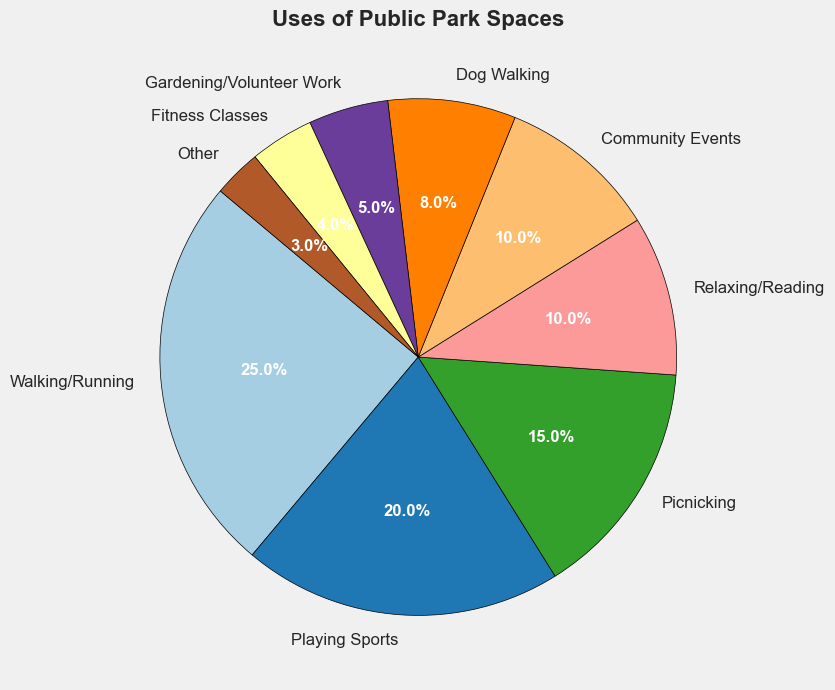What's the largest category of park usage? The figure shows the categories and their corresponding percentages. The largest wedge corresponds to Walking/Running, which takes up 25% of the pie chart.
Answer: Walking/Running Which category uses the least percentage of the park space? By looking at the smallest wedge, we can see that the category "Other" takes up the least percentage of the pie chart at 3%.
Answer: Other How much more percentage is spent on Playing Sports compared to Fitness Classes? Playing Sports accounts for 20% of the pie chart, while Fitness Classes account for 4%. Subtracting the percentage for Fitness Classes from the percentage for Playing Sports (20% - 4%), we get 16%.
Answer: 16% What is the combined percentage for community-oriented activities (Community Events and Gardening/Volunteer Work)? Community Events is 10% and Gardening/Volunteer Work is 5%. Adding these percentages together (10% + 5%), we get a combined percentage of 15%.
Answer: 15% Is the percentage of Dog Walking greater than that of Picnicking? The figure shows that Dog Walking is 8% and Picnicking is 15%. Since 8% is less than 15%, Dog Walking is not greater than Picnicking.
Answer: No What value represents the median of all the percentages shown in the pie chart? To find the median, we need to list all the percentages in order: 3, 4, 5, 8, 10, 10, 15, 20, 25. The middle value is the fifth value in this sorted list, which is 10.
Answer: 10 Compare the percentage of Walking/Running to the combined percentage of Relaxing/Reading and Fitness Classes. Which is larger? Walking/Running is 25%. Relaxing/Reading is 10% and Fitness Classes is 4%. Adding Relaxing/Reading and Fitness Classes together gives 14%. Since 25% is greater than 14%, Walking/Running is larger.
Answer: Walking/Running If the total park area is 100 acres, how many acres are used for Dog Walking? If Dog Walking is 8% of the total park usage, then 8% of 100 acres is 8 acres.
Answer: 8 acres What percentage of the park is used for activities that involve animals? Dog Walking is 8% of the pie chart. None of the other categories explicitly involve animals.
Answer: 8% 